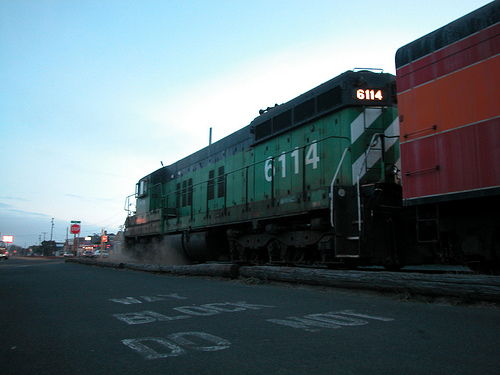What's the significance of the number '6114' on the train? The number '6114' on the train likely serves as an identifier, enabling railway companies to keep track of their rolling stock. It provides a unique identity to that specific locomotive, which can be useful for maintenance, routing, and operational purposes. In a historical context, such numbers can also offer insights into the manufacturing details and the train's service history. 